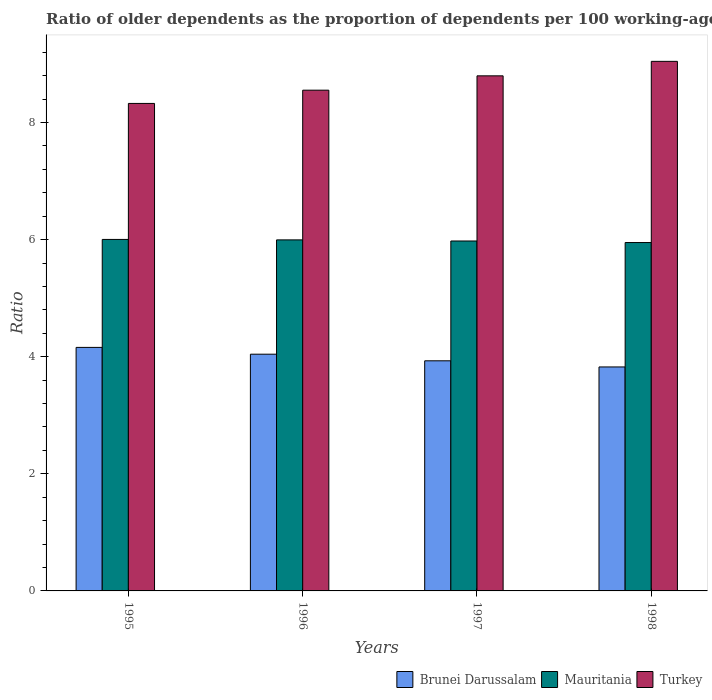How many groups of bars are there?
Provide a succinct answer. 4. Are the number of bars on each tick of the X-axis equal?
Your answer should be very brief. Yes. How many bars are there on the 2nd tick from the left?
Your answer should be very brief. 3. How many bars are there on the 1st tick from the right?
Ensure brevity in your answer.  3. What is the label of the 1st group of bars from the left?
Offer a terse response. 1995. In how many cases, is the number of bars for a given year not equal to the number of legend labels?
Ensure brevity in your answer.  0. What is the age dependency ratio(old) in Mauritania in 1995?
Your response must be concise. 6. Across all years, what is the maximum age dependency ratio(old) in Brunei Darussalam?
Provide a succinct answer. 4.16. Across all years, what is the minimum age dependency ratio(old) in Turkey?
Provide a succinct answer. 8.33. In which year was the age dependency ratio(old) in Turkey maximum?
Provide a succinct answer. 1998. In which year was the age dependency ratio(old) in Mauritania minimum?
Provide a succinct answer. 1998. What is the total age dependency ratio(old) in Brunei Darussalam in the graph?
Keep it short and to the point. 15.96. What is the difference between the age dependency ratio(old) in Mauritania in 1997 and that in 1998?
Your answer should be very brief. 0.03. What is the difference between the age dependency ratio(old) in Mauritania in 1997 and the age dependency ratio(old) in Turkey in 1995?
Provide a short and direct response. -2.35. What is the average age dependency ratio(old) in Turkey per year?
Offer a terse response. 8.68. In the year 1997, what is the difference between the age dependency ratio(old) in Brunei Darussalam and age dependency ratio(old) in Turkey?
Offer a terse response. -4.87. In how many years, is the age dependency ratio(old) in Turkey greater than 3.2?
Provide a short and direct response. 4. What is the ratio of the age dependency ratio(old) in Mauritania in 1995 to that in 1997?
Provide a short and direct response. 1. Is the age dependency ratio(old) in Mauritania in 1997 less than that in 1998?
Ensure brevity in your answer.  No. Is the difference between the age dependency ratio(old) in Brunei Darussalam in 1996 and 1997 greater than the difference between the age dependency ratio(old) in Turkey in 1996 and 1997?
Make the answer very short. Yes. What is the difference between the highest and the second highest age dependency ratio(old) in Brunei Darussalam?
Make the answer very short. 0.12. What is the difference between the highest and the lowest age dependency ratio(old) in Turkey?
Your answer should be compact. 0.72. What does the 2nd bar from the left in 1998 represents?
Your answer should be compact. Mauritania. What does the 3rd bar from the right in 1995 represents?
Provide a succinct answer. Brunei Darussalam. Is it the case that in every year, the sum of the age dependency ratio(old) in Turkey and age dependency ratio(old) in Mauritania is greater than the age dependency ratio(old) in Brunei Darussalam?
Make the answer very short. Yes. How many years are there in the graph?
Your answer should be very brief. 4. What is the difference between two consecutive major ticks on the Y-axis?
Offer a terse response. 2. Does the graph contain grids?
Provide a succinct answer. No. What is the title of the graph?
Ensure brevity in your answer.  Ratio of older dependents as the proportion of dependents per 100 working-age population. Does "Haiti" appear as one of the legend labels in the graph?
Offer a very short reply. No. What is the label or title of the Y-axis?
Make the answer very short. Ratio. What is the Ratio in Brunei Darussalam in 1995?
Make the answer very short. 4.16. What is the Ratio in Mauritania in 1995?
Your answer should be very brief. 6. What is the Ratio in Turkey in 1995?
Your response must be concise. 8.33. What is the Ratio in Brunei Darussalam in 1996?
Keep it short and to the point. 4.04. What is the Ratio in Mauritania in 1996?
Offer a very short reply. 6. What is the Ratio of Turkey in 1996?
Provide a succinct answer. 8.55. What is the Ratio in Brunei Darussalam in 1997?
Ensure brevity in your answer.  3.93. What is the Ratio in Mauritania in 1997?
Your answer should be very brief. 5.98. What is the Ratio of Turkey in 1997?
Your answer should be very brief. 8.8. What is the Ratio in Brunei Darussalam in 1998?
Your answer should be very brief. 3.83. What is the Ratio of Mauritania in 1998?
Your answer should be very brief. 5.95. What is the Ratio in Turkey in 1998?
Provide a succinct answer. 9.04. Across all years, what is the maximum Ratio in Brunei Darussalam?
Make the answer very short. 4.16. Across all years, what is the maximum Ratio in Mauritania?
Offer a terse response. 6. Across all years, what is the maximum Ratio in Turkey?
Offer a very short reply. 9.04. Across all years, what is the minimum Ratio in Brunei Darussalam?
Give a very brief answer. 3.83. Across all years, what is the minimum Ratio of Mauritania?
Give a very brief answer. 5.95. Across all years, what is the minimum Ratio in Turkey?
Ensure brevity in your answer.  8.33. What is the total Ratio of Brunei Darussalam in the graph?
Provide a short and direct response. 15.96. What is the total Ratio of Mauritania in the graph?
Provide a succinct answer. 23.92. What is the total Ratio in Turkey in the graph?
Give a very brief answer. 34.72. What is the difference between the Ratio in Brunei Darussalam in 1995 and that in 1996?
Keep it short and to the point. 0.12. What is the difference between the Ratio in Mauritania in 1995 and that in 1996?
Provide a succinct answer. 0.01. What is the difference between the Ratio of Turkey in 1995 and that in 1996?
Give a very brief answer. -0.23. What is the difference between the Ratio of Brunei Darussalam in 1995 and that in 1997?
Make the answer very short. 0.23. What is the difference between the Ratio of Mauritania in 1995 and that in 1997?
Keep it short and to the point. 0.03. What is the difference between the Ratio of Turkey in 1995 and that in 1997?
Ensure brevity in your answer.  -0.47. What is the difference between the Ratio in Brunei Darussalam in 1995 and that in 1998?
Provide a succinct answer. 0.33. What is the difference between the Ratio of Mauritania in 1995 and that in 1998?
Ensure brevity in your answer.  0.05. What is the difference between the Ratio in Turkey in 1995 and that in 1998?
Your answer should be very brief. -0.72. What is the difference between the Ratio in Brunei Darussalam in 1996 and that in 1997?
Your answer should be very brief. 0.11. What is the difference between the Ratio in Mauritania in 1996 and that in 1997?
Keep it short and to the point. 0.02. What is the difference between the Ratio of Turkey in 1996 and that in 1997?
Offer a very short reply. -0.24. What is the difference between the Ratio in Brunei Darussalam in 1996 and that in 1998?
Provide a succinct answer. 0.22. What is the difference between the Ratio of Mauritania in 1996 and that in 1998?
Provide a succinct answer. 0.05. What is the difference between the Ratio of Turkey in 1996 and that in 1998?
Offer a terse response. -0.49. What is the difference between the Ratio in Brunei Darussalam in 1997 and that in 1998?
Your response must be concise. 0.1. What is the difference between the Ratio in Mauritania in 1997 and that in 1998?
Give a very brief answer. 0.03. What is the difference between the Ratio in Turkey in 1997 and that in 1998?
Provide a short and direct response. -0.25. What is the difference between the Ratio in Brunei Darussalam in 1995 and the Ratio in Mauritania in 1996?
Give a very brief answer. -1.84. What is the difference between the Ratio of Brunei Darussalam in 1995 and the Ratio of Turkey in 1996?
Keep it short and to the point. -4.39. What is the difference between the Ratio in Mauritania in 1995 and the Ratio in Turkey in 1996?
Provide a short and direct response. -2.55. What is the difference between the Ratio of Brunei Darussalam in 1995 and the Ratio of Mauritania in 1997?
Ensure brevity in your answer.  -1.82. What is the difference between the Ratio of Brunei Darussalam in 1995 and the Ratio of Turkey in 1997?
Ensure brevity in your answer.  -4.64. What is the difference between the Ratio of Mauritania in 1995 and the Ratio of Turkey in 1997?
Your response must be concise. -2.79. What is the difference between the Ratio of Brunei Darussalam in 1995 and the Ratio of Mauritania in 1998?
Give a very brief answer. -1.79. What is the difference between the Ratio of Brunei Darussalam in 1995 and the Ratio of Turkey in 1998?
Make the answer very short. -4.89. What is the difference between the Ratio of Mauritania in 1995 and the Ratio of Turkey in 1998?
Offer a very short reply. -3.04. What is the difference between the Ratio in Brunei Darussalam in 1996 and the Ratio in Mauritania in 1997?
Your response must be concise. -1.93. What is the difference between the Ratio in Brunei Darussalam in 1996 and the Ratio in Turkey in 1997?
Offer a very short reply. -4.75. What is the difference between the Ratio in Mauritania in 1996 and the Ratio in Turkey in 1997?
Keep it short and to the point. -2.8. What is the difference between the Ratio in Brunei Darussalam in 1996 and the Ratio in Mauritania in 1998?
Keep it short and to the point. -1.91. What is the difference between the Ratio of Brunei Darussalam in 1996 and the Ratio of Turkey in 1998?
Ensure brevity in your answer.  -5. What is the difference between the Ratio of Mauritania in 1996 and the Ratio of Turkey in 1998?
Keep it short and to the point. -3.05. What is the difference between the Ratio of Brunei Darussalam in 1997 and the Ratio of Mauritania in 1998?
Give a very brief answer. -2.02. What is the difference between the Ratio of Brunei Darussalam in 1997 and the Ratio of Turkey in 1998?
Ensure brevity in your answer.  -5.11. What is the difference between the Ratio in Mauritania in 1997 and the Ratio in Turkey in 1998?
Give a very brief answer. -3.07. What is the average Ratio of Brunei Darussalam per year?
Offer a very short reply. 3.99. What is the average Ratio in Mauritania per year?
Offer a terse response. 5.98. What is the average Ratio in Turkey per year?
Keep it short and to the point. 8.68. In the year 1995, what is the difference between the Ratio in Brunei Darussalam and Ratio in Mauritania?
Provide a short and direct response. -1.84. In the year 1995, what is the difference between the Ratio of Brunei Darussalam and Ratio of Turkey?
Provide a succinct answer. -4.17. In the year 1995, what is the difference between the Ratio in Mauritania and Ratio in Turkey?
Offer a terse response. -2.32. In the year 1996, what is the difference between the Ratio of Brunei Darussalam and Ratio of Mauritania?
Your answer should be compact. -1.95. In the year 1996, what is the difference between the Ratio of Brunei Darussalam and Ratio of Turkey?
Offer a very short reply. -4.51. In the year 1996, what is the difference between the Ratio of Mauritania and Ratio of Turkey?
Your answer should be compact. -2.56. In the year 1997, what is the difference between the Ratio in Brunei Darussalam and Ratio in Mauritania?
Ensure brevity in your answer.  -2.05. In the year 1997, what is the difference between the Ratio of Brunei Darussalam and Ratio of Turkey?
Ensure brevity in your answer.  -4.87. In the year 1997, what is the difference between the Ratio of Mauritania and Ratio of Turkey?
Your response must be concise. -2.82. In the year 1998, what is the difference between the Ratio in Brunei Darussalam and Ratio in Mauritania?
Offer a very short reply. -2.12. In the year 1998, what is the difference between the Ratio of Brunei Darussalam and Ratio of Turkey?
Offer a terse response. -5.22. In the year 1998, what is the difference between the Ratio of Mauritania and Ratio of Turkey?
Offer a terse response. -3.09. What is the ratio of the Ratio in Brunei Darussalam in 1995 to that in 1996?
Give a very brief answer. 1.03. What is the ratio of the Ratio of Mauritania in 1995 to that in 1996?
Make the answer very short. 1. What is the ratio of the Ratio in Turkey in 1995 to that in 1996?
Provide a short and direct response. 0.97. What is the ratio of the Ratio in Brunei Darussalam in 1995 to that in 1997?
Offer a very short reply. 1.06. What is the ratio of the Ratio of Turkey in 1995 to that in 1997?
Provide a short and direct response. 0.95. What is the ratio of the Ratio of Brunei Darussalam in 1995 to that in 1998?
Provide a short and direct response. 1.09. What is the ratio of the Ratio of Turkey in 1995 to that in 1998?
Make the answer very short. 0.92. What is the ratio of the Ratio in Brunei Darussalam in 1996 to that in 1997?
Offer a very short reply. 1.03. What is the ratio of the Ratio of Mauritania in 1996 to that in 1997?
Keep it short and to the point. 1. What is the ratio of the Ratio of Turkey in 1996 to that in 1997?
Offer a terse response. 0.97. What is the ratio of the Ratio in Brunei Darussalam in 1996 to that in 1998?
Provide a succinct answer. 1.06. What is the ratio of the Ratio of Mauritania in 1996 to that in 1998?
Provide a succinct answer. 1.01. What is the ratio of the Ratio of Turkey in 1996 to that in 1998?
Your answer should be very brief. 0.95. What is the ratio of the Ratio of Brunei Darussalam in 1997 to that in 1998?
Your answer should be very brief. 1.03. What is the ratio of the Ratio of Turkey in 1997 to that in 1998?
Your answer should be very brief. 0.97. What is the difference between the highest and the second highest Ratio in Brunei Darussalam?
Your answer should be compact. 0.12. What is the difference between the highest and the second highest Ratio of Mauritania?
Your answer should be compact. 0.01. What is the difference between the highest and the second highest Ratio in Turkey?
Provide a succinct answer. 0.25. What is the difference between the highest and the lowest Ratio in Brunei Darussalam?
Provide a succinct answer. 0.33. What is the difference between the highest and the lowest Ratio of Mauritania?
Make the answer very short. 0.05. What is the difference between the highest and the lowest Ratio of Turkey?
Your response must be concise. 0.72. 